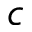Convert formula to latex. <formula><loc_0><loc_0><loc_500><loc_500>c</formula> 